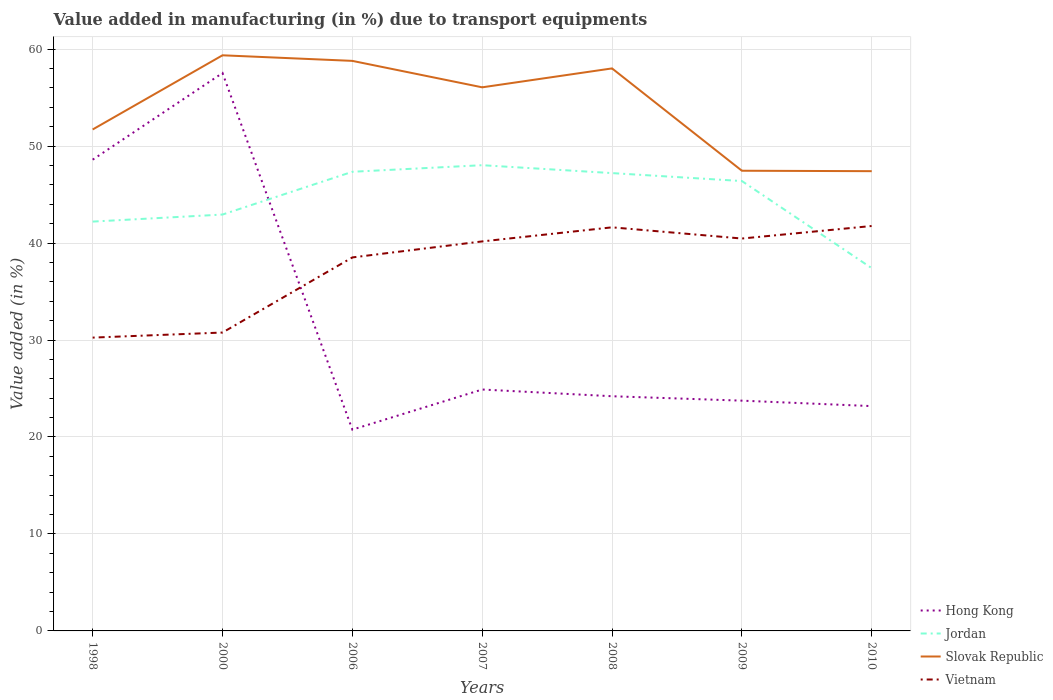How many different coloured lines are there?
Your answer should be very brief. 4. Does the line corresponding to Jordan intersect with the line corresponding to Slovak Republic?
Offer a terse response. No. Across all years, what is the maximum percentage of value added in manufacturing due to transport equipments in Jordan?
Keep it short and to the point. 37.41. What is the total percentage of value added in manufacturing due to transport equipments in Jordan in the graph?
Your answer should be very brief. -0.68. What is the difference between the highest and the second highest percentage of value added in manufacturing due to transport equipments in Hong Kong?
Provide a succinct answer. 36.78. What is the difference between the highest and the lowest percentage of value added in manufacturing due to transport equipments in Slovak Republic?
Your answer should be compact. 4. Is the percentage of value added in manufacturing due to transport equipments in Hong Kong strictly greater than the percentage of value added in manufacturing due to transport equipments in Slovak Republic over the years?
Ensure brevity in your answer.  Yes. How many lines are there?
Give a very brief answer. 4. How many years are there in the graph?
Offer a very short reply. 7. Does the graph contain any zero values?
Make the answer very short. No. What is the title of the graph?
Ensure brevity in your answer.  Value added in manufacturing (in %) due to transport equipments. Does "Israel" appear as one of the legend labels in the graph?
Make the answer very short. No. What is the label or title of the Y-axis?
Offer a very short reply. Value added (in %). What is the Value added (in %) of Hong Kong in 1998?
Your answer should be compact. 48.6. What is the Value added (in %) of Jordan in 1998?
Make the answer very short. 42.21. What is the Value added (in %) in Slovak Republic in 1998?
Give a very brief answer. 51.71. What is the Value added (in %) in Vietnam in 1998?
Your answer should be compact. 30.25. What is the Value added (in %) in Hong Kong in 2000?
Offer a very short reply. 57.54. What is the Value added (in %) of Jordan in 2000?
Offer a very short reply. 42.94. What is the Value added (in %) of Slovak Republic in 2000?
Your answer should be very brief. 59.37. What is the Value added (in %) in Vietnam in 2000?
Offer a terse response. 30.77. What is the Value added (in %) in Hong Kong in 2006?
Your response must be concise. 20.76. What is the Value added (in %) of Jordan in 2006?
Your response must be concise. 47.35. What is the Value added (in %) in Slovak Republic in 2006?
Provide a short and direct response. 58.79. What is the Value added (in %) in Vietnam in 2006?
Your answer should be very brief. 38.52. What is the Value added (in %) of Hong Kong in 2007?
Ensure brevity in your answer.  24.9. What is the Value added (in %) of Jordan in 2007?
Ensure brevity in your answer.  48.03. What is the Value added (in %) in Slovak Republic in 2007?
Your answer should be compact. 56.06. What is the Value added (in %) in Vietnam in 2007?
Make the answer very short. 40.17. What is the Value added (in %) of Hong Kong in 2008?
Provide a succinct answer. 24.2. What is the Value added (in %) of Jordan in 2008?
Offer a terse response. 47.22. What is the Value added (in %) of Slovak Republic in 2008?
Your answer should be compact. 58.01. What is the Value added (in %) in Vietnam in 2008?
Your response must be concise. 41.62. What is the Value added (in %) of Hong Kong in 2009?
Your answer should be compact. 23.75. What is the Value added (in %) of Jordan in 2009?
Offer a terse response. 46.4. What is the Value added (in %) in Slovak Republic in 2009?
Your answer should be very brief. 47.46. What is the Value added (in %) in Vietnam in 2009?
Your answer should be compact. 40.47. What is the Value added (in %) of Hong Kong in 2010?
Give a very brief answer. 23.19. What is the Value added (in %) of Jordan in 2010?
Provide a succinct answer. 37.41. What is the Value added (in %) in Slovak Republic in 2010?
Give a very brief answer. 47.41. What is the Value added (in %) of Vietnam in 2010?
Ensure brevity in your answer.  41.76. Across all years, what is the maximum Value added (in %) of Hong Kong?
Provide a short and direct response. 57.54. Across all years, what is the maximum Value added (in %) in Jordan?
Provide a succinct answer. 48.03. Across all years, what is the maximum Value added (in %) in Slovak Republic?
Your answer should be compact. 59.37. Across all years, what is the maximum Value added (in %) of Vietnam?
Provide a short and direct response. 41.76. Across all years, what is the minimum Value added (in %) in Hong Kong?
Offer a terse response. 20.76. Across all years, what is the minimum Value added (in %) in Jordan?
Keep it short and to the point. 37.41. Across all years, what is the minimum Value added (in %) of Slovak Republic?
Your response must be concise. 47.41. Across all years, what is the minimum Value added (in %) of Vietnam?
Your response must be concise. 30.25. What is the total Value added (in %) in Hong Kong in the graph?
Provide a succinct answer. 222.93. What is the total Value added (in %) of Jordan in the graph?
Your answer should be compact. 311.56. What is the total Value added (in %) of Slovak Republic in the graph?
Offer a terse response. 378.82. What is the total Value added (in %) of Vietnam in the graph?
Keep it short and to the point. 263.57. What is the difference between the Value added (in %) of Hong Kong in 1998 and that in 2000?
Your answer should be very brief. -8.94. What is the difference between the Value added (in %) of Jordan in 1998 and that in 2000?
Provide a short and direct response. -0.73. What is the difference between the Value added (in %) of Slovak Republic in 1998 and that in 2000?
Provide a short and direct response. -7.65. What is the difference between the Value added (in %) of Vietnam in 1998 and that in 2000?
Provide a short and direct response. -0.52. What is the difference between the Value added (in %) of Hong Kong in 1998 and that in 2006?
Keep it short and to the point. 27.84. What is the difference between the Value added (in %) of Jordan in 1998 and that in 2006?
Make the answer very short. -5.14. What is the difference between the Value added (in %) of Slovak Republic in 1998 and that in 2006?
Give a very brief answer. -7.07. What is the difference between the Value added (in %) of Vietnam in 1998 and that in 2006?
Offer a terse response. -8.27. What is the difference between the Value added (in %) in Hong Kong in 1998 and that in 2007?
Provide a succinct answer. 23.7. What is the difference between the Value added (in %) of Jordan in 1998 and that in 2007?
Your answer should be compact. -5.82. What is the difference between the Value added (in %) of Slovak Republic in 1998 and that in 2007?
Give a very brief answer. -4.35. What is the difference between the Value added (in %) in Vietnam in 1998 and that in 2007?
Your answer should be compact. -9.92. What is the difference between the Value added (in %) of Hong Kong in 1998 and that in 2008?
Your answer should be very brief. 24.4. What is the difference between the Value added (in %) in Jordan in 1998 and that in 2008?
Provide a short and direct response. -5. What is the difference between the Value added (in %) in Slovak Republic in 1998 and that in 2008?
Offer a terse response. -6.3. What is the difference between the Value added (in %) in Vietnam in 1998 and that in 2008?
Ensure brevity in your answer.  -11.37. What is the difference between the Value added (in %) in Hong Kong in 1998 and that in 2009?
Your answer should be compact. 24.85. What is the difference between the Value added (in %) of Jordan in 1998 and that in 2009?
Provide a succinct answer. -4.18. What is the difference between the Value added (in %) in Slovak Republic in 1998 and that in 2009?
Keep it short and to the point. 4.25. What is the difference between the Value added (in %) of Vietnam in 1998 and that in 2009?
Keep it short and to the point. -10.22. What is the difference between the Value added (in %) of Hong Kong in 1998 and that in 2010?
Provide a short and direct response. 25.41. What is the difference between the Value added (in %) of Jordan in 1998 and that in 2010?
Keep it short and to the point. 4.8. What is the difference between the Value added (in %) of Slovak Republic in 1998 and that in 2010?
Your answer should be very brief. 4.3. What is the difference between the Value added (in %) of Vietnam in 1998 and that in 2010?
Offer a terse response. -11.51. What is the difference between the Value added (in %) of Hong Kong in 2000 and that in 2006?
Your response must be concise. 36.78. What is the difference between the Value added (in %) in Jordan in 2000 and that in 2006?
Offer a terse response. -4.41. What is the difference between the Value added (in %) of Slovak Republic in 2000 and that in 2006?
Provide a succinct answer. 0.58. What is the difference between the Value added (in %) in Vietnam in 2000 and that in 2006?
Your answer should be compact. -7.75. What is the difference between the Value added (in %) of Hong Kong in 2000 and that in 2007?
Give a very brief answer. 32.64. What is the difference between the Value added (in %) of Jordan in 2000 and that in 2007?
Ensure brevity in your answer.  -5.09. What is the difference between the Value added (in %) of Slovak Republic in 2000 and that in 2007?
Offer a terse response. 3.3. What is the difference between the Value added (in %) in Vietnam in 2000 and that in 2007?
Give a very brief answer. -9.4. What is the difference between the Value added (in %) in Hong Kong in 2000 and that in 2008?
Your response must be concise. 33.33. What is the difference between the Value added (in %) in Jordan in 2000 and that in 2008?
Your response must be concise. -4.28. What is the difference between the Value added (in %) of Slovak Republic in 2000 and that in 2008?
Offer a very short reply. 1.35. What is the difference between the Value added (in %) of Vietnam in 2000 and that in 2008?
Ensure brevity in your answer.  -10.85. What is the difference between the Value added (in %) in Hong Kong in 2000 and that in 2009?
Keep it short and to the point. 33.79. What is the difference between the Value added (in %) of Jordan in 2000 and that in 2009?
Your answer should be compact. -3.46. What is the difference between the Value added (in %) in Slovak Republic in 2000 and that in 2009?
Offer a very short reply. 11.91. What is the difference between the Value added (in %) in Vietnam in 2000 and that in 2009?
Your response must be concise. -9.69. What is the difference between the Value added (in %) in Hong Kong in 2000 and that in 2010?
Your answer should be very brief. 34.35. What is the difference between the Value added (in %) of Jordan in 2000 and that in 2010?
Give a very brief answer. 5.53. What is the difference between the Value added (in %) in Slovak Republic in 2000 and that in 2010?
Make the answer very short. 11.95. What is the difference between the Value added (in %) in Vietnam in 2000 and that in 2010?
Provide a short and direct response. -10.99. What is the difference between the Value added (in %) of Hong Kong in 2006 and that in 2007?
Offer a terse response. -4.14. What is the difference between the Value added (in %) in Jordan in 2006 and that in 2007?
Your answer should be very brief. -0.68. What is the difference between the Value added (in %) in Slovak Republic in 2006 and that in 2007?
Offer a terse response. 2.73. What is the difference between the Value added (in %) of Vietnam in 2006 and that in 2007?
Ensure brevity in your answer.  -1.65. What is the difference between the Value added (in %) of Hong Kong in 2006 and that in 2008?
Make the answer very short. -3.44. What is the difference between the Value added (in %) in Jordan in 2006 and that in 2008?
Your response must be concise. 0.14. What is the difference between the Value added (in %) of Slovak Republic in 2006 and that in 2008?
Give a very brief answer. 0.78. What is the difference between the Value added (in %) of Vietnam in 2006 and that in 2008?
Provide a short and direct response. -3.1. What is the difference between the Value added (in %) of Hong Kong in 2006 and that in 2009?
Ensure brevity in your answer.  -2.99. What is the difference between the Value added (in %) of Jordan in 2006 and that in 2009?
Give a very brief answer. 0.96. What is the difference between the Value added (in %) in Slovak Republic in 2006 and that in 2009?
Your response must be concise. 11.33. What is the difference between the Value added (in %) of Vietnam in 2006 and that in 2009?
Your answer should be compact. -1.95. What is the difference between the Value added (in %) of Hong Kong in 2006 and that in 2010?
Your answer should be very brief. -2.43. What is the difference between the Value added (in %) in Jordan in 2006 and that in 2010?
Keep it short and to the point. 9.94. What is the difference between the Value added (in %) of Slovak Republic in 2006 and that in 2010?
Your answer should be very brief. 11.38. What is the difference between the Value added (in %) in Vietnam in 2006 and that in 2010?
Give a very brief answer. -3.24. What is the difference between the Value added (in %) of Hong Kong in 2007 and that in 2008?
Your response must be concise. 0.69. What is the difference between the Value added (in %) of Jordan in 2007 and that in 2008?
Provide a succinct answer. 0.81. What is the difference between the Value added (in %) in Slovak Republic in 2007 and that in 2008?
Your answer should be compact. -1.95. What is the difference between the Value added (in %) of Vietnam in 2007 and that in 2008?
Provide a short and direct response. -1.45. What is the difference between the Value added (in %) of Hong Kong in 2007 and that in 2009?
Offer a terse response. 1.15. What is the difference between the Value added (in %) in Jordan in 2007 and that in 2009?
Your answer should be very brief. 1.63. What is the difference between the Value added (in %) in Slovak Republic in 2007 and that in 2009?
Your response must be concise. 8.6. What is the difference between the Value added (in %) in Vietnam in 2007 and that in 2009?
Offer a terse response. -0.3. What is the difference between the Value added (in %) in Hong Kong in 2007 and that in 2010?
Make the answer very short. 1.71. What is the difference between the Value added (in %) of Jordan in 2007 and that in 2010?
Ensure brevity in your answer.  10.62. What is the difference between the Value added (in %) of Slovak Republic in 2007 and that in 2010?
Your answer should be compact. 8.65. What is the difference between the Value added (in %) in Vietnam in 2007 and that in 2010?
Offer a terse response. -1.59. What is the difference between the Value added (in %) of Hong Kong in 2008 and that in 2009?
Your response must be concise. 0.46. What is the difference between the Value added (in %) of Jordan in 2008 and that in 2009?
Your answer should be very brief. 0.82. What is the difference between the Value added (in %) of Slovak Republic in 2008 and that in 2009?
Make the answer very short. 10.55. What is the difference between the Value added (in %) in Vietnam in 2008 and that in 2009?
Your answer should be compact. 1.16. What is the difference between the Value added (in %) of Hong Kong in 2008 and that in 2010?
Ensure brevity in your answer.  1.02. What is the difference between the Value added (in %) in Jordan in 2008 and that in 2010?
Your answer should be compact. 9.8. What is the difference between the Value added (in %) in Slovak Republic in 2008 and that in 2010?
Your answer should be very brief. 10.6. What is the difference between the Value added (in %) in Vietnam in 2008 and that in 2010?
Offer a very short reply. -0.14. What is the difference between the Value added (in %) in Hong Kong in 2009 and that in 2010?
Provide a short and direct response. 0.56. What is the difference between the Value added (in %) of Jordan in 2009 and that in 2010?
Make the answer very short. 8.98. What is the difference between the Value added (in %) in Slovak Republic in 2009 and that in 2010?
Offer a terse response. 0.05. What is the difference between the Value added (in %) of Vietnam in 2009 and that in 2010?
Keep it short and to the point. -1.29. What is the difference between the Value added (in %) of Hong Kong in 1998 and the Value added (in %) of Jordan in 2000?
Ensure brevity in your answer.  5.66. What is the difference between the Value added (in %) of Hong Kong in 1998 and the Value added (in %) of Slovak Republic in 2000?
Offer a very short reply. -10.77. What is the difference between the Value added (in %) of Hong Kong in 1998 and the Value added (in %) of Vietnam in 2000?
Ensure brevity in your answer.  17.83. What is the difference between the Value added (in %) of Jordan in 1998 and the Value added (in %) of Slovak Republic in 2000?
Ensure brevity in your answer.  -17.15. What is the difference between the Value added (in %) of Jordan in 1998 and the Value added (in %) of Vietnam in 2000?
Offer a very short reply. 11.44. What is the difference between the Value added (in %) of Slovak Republic in 1998 and the Value added (in %) of Vietnam in 2000?
Your answer should be compact. 20.94. What is the difference between the Value added (in %) of Hong Kong in 1998 and the Value added (in %) of Jordan in 2006?
Your response must be concise. 1.25. What is the difference between the Value added (in %) of Hong Kong in 1998 and the Value added (in %) of Slovak Republic in 2006?
Give a very brief answer. -10.19. What is the difference between the Value added (in %) in Hong Kong in 1998 and the Value added (in %) in Vietnam in 2006?
Your answer should be compact. 10.08. What is the difference between the Value added (in %) in Jordan in 1998 and the Value added (in %) in Slovak Republic in 2006?
Your answer should be very brief. -16.57. What is the difference between the Value added (in %) of Jordan in 1998 and the Value added (in %) of Vietnam in 2006?
Your answer should be compact. 3.69. What is the difference between the Value added (in %) of Slovak Republic in 1998 and the Value added (in %) of Vietnam in 2006?
Ensure brevity in your answer.  13.19. What is the difference between the Value added (in %) in Hong Kong in 1998 and the Value added (in %) in Jordan in 2007?
Your response must be concise. 0.57. What is the difference between the Value added (in %) in Hong Kong in 1998 and the Value added (in %) in Slovak Republic in 2007?
Provide a short and direct response. -7.46. What is the difference between the Value added (in %) of Hong Kong in 1998 and the Value added (in %) of Vietnam in 2007?
Offer a very short reply. 8.43. What is the difference between the Value added (in %) of Jordan in 1998 and the Value added (in %) of Slovak Republic in 2007?
Offer a terse response. -13.85. What is the difference between the Value added (in %) of Jordan in 1998 and the Value added (in %) of Vietnam in 2007?
Provide a short and direct response. 2.04. What is the difference between the Value added (in %) of Slovak Republic in 1998 and the Value added (in %) of Vietnam in 2007?
Your answer should be compact. 11.54. What is the difference between the Value added (in %) in Hong Kong in 1998 and the Value added (in %) in Jordan in 2008?
Your response must be concise. 1.38. What is the difference between the Value added (in %) in Hong Kong in 1998 and the Value added (in %) in Slovak Republic in 2008?
Provide a succinct answer. -9.41. What is the difference between the Value added (in %) of Hong Kong in 1998 and the Value added (in %) of Vietnam in 2008?
Ensure brevity in your answer.  6.98. What is the difference between the Value added (in %) in Jordan in 1998 and the Value added (in %) in Slovak Republic in 2008?
Your response must be concise. -15.8. What is the difference between the Value added (in %) of Jordan in 1998 and the Value added (in %) of Vietnam in 2008?
Give a very brief answer. 0.59. What is the difference between the Value added (in %) in Slovak Republic in 1998 and the Value added (in %) in Vietnam in 2008?
Offer a very short reply. 10.09. What is the difference between the Value added (in %) in Hong Kong in 1998 and the Value added (in %) in Jordan in 2009?
Your answer should be very brief. 2.2. What is the difference between the Value added (in %) of Hong Kong in 1998 and the Value added (in %) of Slovak Republic in 2009?
Offer a very short reply. 1.14. What is the difference between the Value added (in %) of Hong Kong in 1998 and the Value added (in %) of Vietnam in 2009?
Provide a short and direct response. 8.13. What is the difference between the Value added (in %) of Jordan in 1998 and the Value added (in %) of Slovak Republic in 2009?
Offer a terse response. -5.25. What is the difference between the Value added (in %) in Jordan in 1998 and the Value added (in %) in Vietnam in 2009?
Offer a terse response. 1.75. What is the difference between the Value added (in %) in Slovak Republic in 1998 and the Value added (in %) in Vietnam in 2009?
Your response must be concise. 11.25. What is the difference between the Value added (in %) in Hong Kong in 1998 and the Value added (in %) in Jordan in 2010?
Your answer should be compact. 11.19. What is the difference between the Value added (in %) of Hong Kong in 1998 and the Value added (in %) of Slovak Republic in 2010?
Give a very brief answer. 1.19. What is the difference between the Value added (in %) of Hong Kong in 1998 and the Value added (in %) of Vietnam in 2010?
Provide a succinct answer. 6.84. What is the difference between the Value added (in %) in Jordan in 1998 and the Value added (in %) in Slovak Republic in 2010?
Your answer should be compact. -5.2. What is the difference between the Value added (in %) of Jordan in 1998 and the Value added (in %) of Vietnam in 2010?
Your response must be concise. 0.45. What is the difference between the Value added (in %) of Slovak Republic in 1998 and the Value added (in %) of Vietnam in 2010?
Offer a very short reply. 9.95. What is the difference between the Value added (in %) of Hong Kong in 2000 and the Value added (in %) of Jordan in 2006?
Your response must be concise. 10.18. What is the difference between the Value added (in %) of Hong Kong in 2000 and the Value added (in %) of Slovak Republic in 2006?
Your answer should be very brief. -1.25. What is the difference between the Value added (in %) of Hong Kong in 2000 and the Value added (in %) of Vietnam in 2006?
Your answer should be very brief. 19.02. What is the difference between the Value added (in %) of Jordan in 2000 and the Value added (in %) of Slovak Republic in 2006?
Provide a succinct answer. -15.85. What is the difference between the Value added (in %) in Jordan in 2000 and the Value added (in %) in Vietnam in 2006?
Keep it short and to the point. 4.42. What is the difference between the Value added (in %) of Slovak Republic in 2000 and the Value added (in %) of Vietnam in 2006?
Your answer should be compact. 20.85. What is the difference between the Value added (in %) in Hong Kong in 2000 and the Value added (in %) in Jordan in 2007?
Offer a very short reply. 9.5. What is the difference between the Value added (in %) of Hong Kong in 2000 and the Value added (in %) of Slovak Republic in 2007?
Offer a very short reply. 1.47. What is the difference between the Value added (in %) of Hong Kong in 2000 and the Value added (in %) of Vietnam in 2007?
Offer a terse response. 17.36. What is the difference between the Value added (in %) in Jordan in 2000 and the Value added (in %) in Slovak Republic in 2007?
Provide a short and direct response. -13.12. What is the difference between the Value added (in %) in Jordan in 2000 and the Value added (in %) in Vietnam in 2007?
Your response must be concise. 2.77. What is the difference between the Value added (in %) of Slovak Republic in 2000 and the Value added (in %) of Vietnam in 2007?
Provide a succinct answer. 19.19. What is the difference between the Value added (in %) of Hong Kong in 2000 and the Value added (in %) of Jordan in 2008?
Offer a very short reply. 10.32. What is the difference between the Value added (in %) of Hong Kong in 2000 and the Value added (in %) of Slovak Republic in 2008?
Provide a succinct answer. -0.48. What is the difference between the Value added (in %) of Hong Kong in 2000 and the Value added (in %) of Vietnam in 2008?
Offer a terse response. 15.91. What is the difference between the Value added (in %) of Jordan in 2000 and the Value added (in %) of Slovak Republic in 2008?
Your response must be concise. -15.07. What is the difference between the Value added (in %) in Jordan in 2000 and the Value added (in %) in Vietnam in 2008?
Offer a terse response. 1.32. What is the difference between the Value added (in %) of Slovak Republic in 2000 and the Value added (in %) of Vietnam in 2008?
Ensure brevity in your answer.  17.74. What is the difference between the Value added (in %) in Hong Kong in 2000 and the Value added (in %) in Jordan in 2009?
Provide a short and direct response. 11.14. What is the difference between the Value added (in %) of Hong Kong in 2000 and the Value added (in %) of Slovak Republic in 2009?
Make the answer very short. 10.08. What is the difference between the Value added (in %) in Hong Kong in 2000 and the Value added (in %) in Vietnam in 2009?
Provide a short and direct response. 17.07. What is the difference between the Value added (in %) of Jordan in 2000 and the Value added (in %) of Slovak Republic in 2009?
Provide a succinct answer. -4.52. What is the difference between the Value added (in %) in Jordan in 2000 and the Value added (in %) in Vietnam in 2009?
Ensure brevity in your answer.  2.47. What is the difference between the Value added (in %) of Slovak Republic in 2000 and the Value added (in %) of Vietnam in 2009?
Your answer should be very brief. 18.9. What is the difference between the Value added (in %) in Hong Kong in 2000 and the Value added (in %) in Jordan in 2010?
Give a very brief answer. 20.12. What is the difference between the Value added (in %) of Hong Kong in 2000 and the Value added (in %) of Slovak Republic in 2010?
Provide a short and direct response. 10.12. What is the difference between the Value added (in %) in Hong Kong in 2000 and the Value added (in %) in Vietnam in 2010?
Provide a succinct answer. 15.77. What is the difference between the Value added (in %) of Jordan in 2000 and the Value added (in %) of Slovak Republic in 2010?
Provide a succinct answer. -4.47. What is the difference between the Value added (in %) of Jordan in 2000 and the Value added (in %) of Vietnam in 2010?
Your response must be concise. 1.18. What is the difference between the Value added (in %) of Slovak Republic in 2000 and the Value added (in %) of Vietnam in 2010?
Ensure brevity in your answer.  17.6. What is the difference between the Value added (in %) of Hong Kong in 2006 and the Value added (in %) of Jordan in 2007?
Offer a terse response. -27.27. What is the difference between the Value added (in %) of Hong Kong in 2006 and the Value added (in %) of Slovak Republic in 2007?
Offer a very short reply. -35.3. What is the difference between the Value added (in %) in Hong Kong in 2006 and the Value added (in %) in Vietnam in 2007?
Give a very brief answer. -19.41. What is the difference between the Value added (in %) in Jordan in 2006 and the Value added (in %) in Slovak Republic in 2007?
Provide a short and direct response. -8.71. What is the difference between the Value added (in %) of Jordan in 2006 and the Value added (in %) of Vietnam in 2007?
Your response must be concise. 7.18. What is the difference between the Value added (in %) in Slovak Republic in 2006 and the Value added (in %) in Vietnam in 2007?
Provide a succinct answer. 18.62. What is the difference between the Value added (in %) in Hong Kong in 2006 and the Value added (in %) in Jordan in 2008?
Ensure brevity in your answer.  -26.46. What is the difference between the Value added (in %) of Hong Kong in 2006 and the Value added (in %) of Slovak Republic in 2008?
Make the answer very short. -37.25. What is the difference between the Value added (in %) of Hong Kong in 2006 and the Value added (in %) of Vietnam in 2008?
Your answer should be compact. -20.86. What is the difference between the Value added (in %) of Jordan in 2006 and the Value added (in %) of Slovak Republic in 2008?
Give a very brief answer. -10.66. What is the difference between the Value added (in %) of Jordan in 2006 and the Value added (in %) of Vietnam in 2008?
Ensure brevity in your answer.  5.73. What is the difference between the Value added (in %) of Slovak Republic in 2006 and the Value added (in %) of Vietnam in 2008?
Provide a short and direct response. 17.17. What is the difference between the Value added (in %) of Hong Kong in 2006 and the Value added (in %) of Jordan in 2009?
Offer a terse response. -25.64. What is the difference between the Value added (in %) of Hong Kong in 2006 and the Value added (in %) of Slovak Republic in 2009?
Your response must be concise. -26.7. What is the difference between the Value added (in %) of Hong Kong in 2006 and the Value added (in %) of Vietnam in 2009?
Your answer should be compact. -19.71. What is the difference between the Value added (in %) in Jordan in 2006 and the Value added (in %) in Slovak Republic in 2009?
Your answer should be compact. -0.11. What is the difference between the Value added (in %) of Jordan in 2006 and the Value added (in %) of Vietnam in 2009?
Keep it short and to the point. 6.89. What is the difference between the Value added (in %) of Slovak Republic in 2006 and the Value added (in %) of Vietnam in 2009?
Your answer should be compact. 18.32. What is the difference between the Value added (in %) of Hong Kong in 2006 and the Value added (in %) of Jordan in 2010?
Offer a very short reply. -16.65. What is the difference between the Value added (in %) of Hong Kong in 2006 and the Value added (in %) of Slovak Republic in 2010?
Offer a very short reply. -26.65. What is the difference between the Value added (in %) of Hong Kong in 2006 and the Value added (in %) of Vietnam in 2010?
Offer a very short reply. -21. What is the difference between the Value added (in %) of Jordan in 2006 and the Value added (in %) of Slovak Republic in 2010?
Give a very brief answer. -0.06. What is the difference between the Value added (in %) of Jordan in 2006 and the Value added (in %) of Vietnam in 2010?
Your answer should be compact. 5.59. What is the difference between the Value added (in %) of Slovak Republic in 2006 and the Value added (in %) of Vietnam in 2010?
Your answer should be very brief. 17.03. What is the difference between the Value added (in %) in Hong Kong in 2007 and the Value added (in %) in Jordan in 2008?
Provide a short and direct response. -22.32. What is the difference between the Value added (in %) of Hong Kong in 2007 and the Value added (in %) of Slovak Republic in 2008?
Offer a very short reply. -33.12. What is the difference between the Value added (in %) of Hong Kong in 2007 and the Value added (in %) of Vietnam in 2008?
Offer a terse response. -16.73. What is the difference between the Value added (in %) in Jordan in 2007 and the Value added (in %) in Slovak Republic in 2008?
Keep it short and to the point. -9.98. What is the difference between the Value added (in %) of Jordan in 2007 and the Value added (in %) of Vietnam in 2008?
Keep it short and to the point. 6.41. What is the difference between the Value added (in %) in Slovak Republic in 2007 and the Value added (in %) in Vietnam in 2008?
Offer a terse response. 14.44. What is the difference between the Value added (in %) in Hong Kong in 2007 and the Value added (in %) in Jordan in 2009?
Give a very brief answer. -21.5. What is the difference between the Value added (in %) of Hong Kong in 2007 and the Value added (in %) of Slovak Republic in 2009?
Keep it short and to the point. -22.56. What is the difference between the Value added (in %) in Hong Kong in 2007 and the Value added (in %) in Vietnam in 2009?
Make the answer very short. -15.57. What is the difference between the Value added (in %) in Jordan in 2007 and the Value added (in %) in Slovak Republic in 2009?
Give a very brief answer. 0.57. What is the difference between the Value added (in %) in Jordan in 2007 and the Value added (in %) in Vietnam in 2009?
Offer a terse response. 7.56. What is the difference between the Value added (in %) in Slovak Republic in 2007 and the Value added (in %) in Vietnam in 2009?
Ensure brevity in your answer.  15.6. What is the difference between the Value added (in %) in Hong Kong in 2007 and the Value added (in %) in Jordan in 2010?
Give a very brief answer. -12.52. What is the difference between the Value added (in %) in Hong Kong in 2007 and the Value added (in %) in Slovak Republic in 2010?
Your response must be concise. -22.52. What is the difference between the Value added (in %) in Hong Kong in 2007 and the Value added (in %) in Vietnam in 2010?
Provide a succinct answer. -16.86. What is the difference between the Value added (in %) of Jordan in 2007 and the Value added (in %) of Slovak Republic in 2010?
Make the answer very short. 0.62. What is the difference between the Value added (in %) in Jordan in 2007 and the Value added (in %) in Vietnam in 2010?
Provide a short and direct response. 6.27. What is the difference between the Value added (in %) of Slovak Republic in 2007 and the Value added (in %) of Vietnam in 2010?
Make the answer very short. 14.3. What is the difference between the Value added (in %) in Hong Kong in 2008 and the Value added (in %) in Jordan in 2009?
Provide a succinct answer. -22.19. What is the difference between the Value added (in %) in Hong Kong in 2008 and the Value added (in %) in Slovak Republic in 2009?
Make the answer very short. -23.26. What is the difference between the Value added (in %) of Hong Kong in 2008 and the Value added (in %) of Vietnam in 2009?
Offer a terse response. -16.26. What is the difference between the Value added (in %) of Jordan in 2008 and the Value added (in %) of Slovak Republic in 2009?
Provide a succinct answer. -0.24. What is the difference between the Value added (in %) in Jordan in 2008 and the Value added (in %) in Vietnam in 2009?
Your response must be concise. 6.75. What is the difference between the Value added (in %) of Slovak Republic in 2008 and the Value added (in %) of Vietnam in 2009?
Your answer should be very brief. 17.55. What is the difference between the Value added (in %) of Hong Kong in 2008 and the Value added (in %) of Jordan in 2010?
Give a very brief answer. -13.21. What is the difference between the Value added (in %) in Hong Kong in 2008 and the Value added (in %) in Slovak Republic in 2010?
Ensure brevity in your answer.  -23.21. What is the difference between the Value added (in %) of Hong Kong in 2008 and the Value added (in %) of Vietnam in 2010?
Provide a short and direct response. -17.56. What is the difference between the Value added (in %) in Jordan in 2008 and the Value added (in %) in Slovak Republic in 2010?
Provide a succinct answer. -0.2. What is the difference between the Value added (in %) in Jordan in 2008 and the Value added (in %) in Vietnam in 2010?
Your response must be concise. 5.46. What is the difference between the Value added (in %) of Slovak Republic in 2008 and the Value added (in %) of Vietnam in 2010?
Ensure brevity in your answer.  16.25. What is the difference between the Value added (in %) in Hong Kong in 2009 and the Value added (in %) in Jordan in 2010?
Give a very brief answer. -13.66. What is the difference between the Value added (in %) in Hong Kong in 2009 and the Value added (in %) in Slovak Republic in 2010?
Your answer should be very brief. -23.67. What is the difference between the Value added (in %) of Hong Kong in 2009 and the Value added (in %) of Vietnam in 2010?
Offer a terse response. -18.01. What is the difference between the Value added (in %) in Jordan in 2009 and the Value added (in %) in Slovak Republic in 2010?
Your answer should be compact. -1.02. What is the difference between the Value added (in %) in Jordan in 2009 and the Value added (in %) in Vietnam in 2010?
Offer a terse response. 4.64. What is the difference between the Value added (in %) of Slovak Republic in 2009 and the Value added (in %) of Vietnam in 2010?
Offer a very short reply. 5.7. What is the average Value added (in %) of Hong Kong per year?
Ensure brevity in your answer.  31.85. What is the average Value added (in %) of Jordan per year?
Keep it short and to the point. 44.51. What is the average Value added (in %) of Slovak Republic per year?
Give a very brief answer. 54.12. What is the average Value added (in %) in Vietnam per year?
Offer a very short reply. 37.65. In the year 1998, what is the difference between the Value added (in %) of Hong Kong and Value added (in %) of Jordan?
Ensure brevity in your answer.  6.39. In the year 1998, what is the difference between the Value added (in %) in Hong Kong and Value added (in %) in Slovak Republic?
Give a very brief answer. -3.11. In the year 1998, what is the difference between the Value added (in %) in Hong Kong and Value added (in %) in Vietnam?
Keep it short and to the point. 18.35. In the year 1998, what is the difference between the Value added (in %) in Jordan and Value added (in %) in Slovak Republic?
Provide a short and direct response. -9.5. In the year 1998, what is the difference between the Value added (in %) in Jordan and Value added (in %) in Vietnam?
Keep it short and to the point. 11.96. In the year 1998, what is the difference between the Value added (in %) in Slovak Republic and Value added (in %) in Vietnam?
Make the answer very short. 21.46. In the year 2000, what is the difference between the Value added (in %) of Hong Kong and Value added (in %) of Jordan?
Make the answer very short. 14.59. In the year 2000, what is the difference between the Value added (in %) in Hong Kong and Value added (in %) in Slovak Republic?
Offer a terse response. -1.83. In the year 2000, what is the difference between the Value added (in %) in Hong Kong and Value added (in %) in Vietnam?
Your answer should be compact. 26.76. In the year 2000, what is the difference between the Value added (in %) in Jordan and Value added (in %) in Slovak Republic?
Give a very brief answer. -16.42. In the year 2000, what is the difference between the Value added (in %) in Jordan and Value added (in %) in Vietnam?
Your answer should be very brief. 12.17. In the year 2000, what is the difference between the Value added (in %) of Slovak Republic and Value added (in %) of Vietnam?
Your response must be concise. 28.59. In the year 2006, what is the difference between the Value added (in %) of Hong Kong and Value added (in %) of Jordan?
Give a very brief answer. -26.59. In the year 2006, what is the difference between the Value added (in %) of Hong Kong and Value added (in %) of Slovak Republic?
Give a very brief answer. -38.03. In the year 2006, what is the difference between the Value added (in %) in Hong Kong and Value added (in %) in Vietnam?
Make the answer very short. -17.76. In the year 2006, what is the difference between the Value added (in %) in Jordan and Value added (in %) in Slovak Republic?
Ensure brevity in your answer.  -11.44. In the year 2006, what is the difference between the Value added (in %) of Jordan and Value added (in %) of Vietnam?
Ensure brevity in your answer.  8.83. In the year 2006, what is the difference between the Value added (in %) in Slovak Republic and Value added (in %) in Vietnam?
Make the answer very short. 20.27. In the year 2007, what is the difference between the Value added (in %) of Hong Kong and Value added (in %) of Jordan?
Make the answer very short. -23.13. In the year 2007, what is the difference between the Value added (in %) in Hong Kong and Value added (in %) in Slovak Republic?
Your answer should be very brief. -31.17. In the year 2007, what is the difference between the Value added (in %) of Hong Kong and Value added (in %) of Vietnam?
Provide a short and direct response. -15.27. In the year 2007, what is the difference between the Value added (in %) of Jordan and Value added (in %) of Slovak Republic?
Keep it short and to the point. -8.03. In the year 2007, what is the difference between the Value added (in %) in Jordan and Value added (in %) in Vietnam?
Offer a very short reply. 7.86. In the year 2007, what is the difference between the Value added (in %) of Slovak Republic and Value added (in %) of Vietnam?
Make the answer very short. 15.89. In the year 2008, what is the difference between the Value added (in %) in Hong Kong and Value added (in %) in Jordan?
Your answer should be compact. -23.01. In the year 2008, what is the difference between the Value added (in %) of Hong Kong and Value added (in %) of Slovak Republic?
Provide a short and direct response. -33.81. In the year 2008, what is the difference between the Value added (in %) in Hong Kong and Value added (in %) in Vietnam?
Your answer should be very brief. -17.42. In the year 2008, what is the difference between the Value added (in %) of Jordan and Value added (in %) of Slovak Republic?
Ensure brevity in your answer.  -10.8. In the year 2008, what is the difference between the Value added (in %) of Jordan and Value added (in %) of Vietnam?
Your response must be concise. 5.59. In the year 2008, what is the difference between the Value added (in %) of Slovak Republic and Value added (in %) of Vietnam?
Give a very brief answer. 16.39. In the year 2009, what is the difference between the Value added (in %) of Hong Kong and Value added (in %) of Jordan?
Your response must be concise. -22.65. In the year 2009, what is the difference between the Value added (in %) of Hong Kong and Value added (in %) of Slovak Republic?
Keep it short and to the point. -23.71. In the year 2009, what is the difference between the Value added (in %) in Hong Kong and Value added (in %) in Vietnam?
Your answer should be compact. -16.72. In the year 2009, what is the difference between the Value added (in %) in Jordan and Value added (in %) in Slovak Republic?
Keep it short and to the point. -1.06. In the year 2009, what is the difference between the Value added (in %) of Jordan and Value added (in %) of Vietnam?
Your answer should be very brief. 5.93. In the year 2009, what is the difference between the Value added (in %) of Slovak Republic and Value added (in %) of Vietnam?
Your response must be concise. 6.99. In the year 2010, what is the difference between the Value added (in %) of Hong Kong and Value added (in %) of Jordan?
Your answer should be very brief. -14.23. In the year 2010, what is the difference between the Value added (in %) in Hong Kong and Value added (in %) in Slovak Republic?
Offer a terse response. -24.23. In the year 2010, what is the difference between the Value added (in %) in Hong Kong and Value added (in %) in Vietnam?
Make the answer very short. -18.58. In the year 2010, what is the difference between the Value added (in %) of Jordan and Value added (in %) of Slovak Republic?
Your answer should be compact. -10. In the year 2010, what is the difference between the Value added (in %) in Jordan and Value added (in %) in Vietnam?
Keep it short and to the point. -4.35. In the year 2010, what is the difference between the Value added (in %) of Slovak Republic and Value added (in %) of Vietnam?
Offer a terse response. 5.65. What is the ratio of the Value added (in %) in Hong Kong in 1998 to that in 2000?
Give a very brief answer. 0.84. What is the ratio of the Value added (in %) of Jordan in 1998 to that in 2000?
Provide a short and direct response. 0.98. What is the ratio of the Value added (in %) of Slovak Republic in 1998 to that in 2000?
Your answer should be very brief. 0.87. What is the ratio of the Value added (in %) of Vietnam in 1998 to that in 2000?
Give a very brief answer. 0.98. What is the ratio of the Value added (in %) of Hong Kong in 1998 to that in 2006?
Make the answer very short. 2.34. What is the ratio of the Value added (in %) of Jordan in 1998 to that in 2006?
Offer a very short reply. 0.89. What is the ratio of the Value added (in %) of Slovak Republic in 1998 to that in 2006?
Your answer should be very brief. 0.88. What is the ratio of the Value added (in %) in Vietnam in 1998 to that in 2006?
Offer a very short reply. 0.79. What is the ratio of the Value added (in %) in Hong Kong in 1998 to that in 2007?
Your response must be concise. 1.95. What is the ratio of the Value added (in %) of Jordan in 1998 to that in 2007?
Provide a short and direct response. 0.88. What is the ratio of the Value added (in %) of Slovak Republic in 1998 to that in 2007?
Ensure brevity in your answer.  0.92. What is the ratio of the Value added (in %) of Vietnam in 1998 to that in 2007?
Make the answer very short. 0.75. What is the ratio of the Value added (in %) of Hong Kong in 1998 to that in 2008?
Provide a short and direct response. 2.01. What is the ratio of the Value added (in %) of Jordan in 1998 to that in 2008?
Offer a terse response. 0.89. What is the ratio of the Value added (in %) of Slovak Republic in 1998 to that in 2008?
Ensure brevity in your answer.  0.89. What is the ratio of the Value added (in %) in Vietnam in 1998 to that in 2008?
Your answer should be compact. 0.73. What is the ratio of the Value added (in %) in Hong Kong in 1998 to that in 2009?
Your answer should be compact. 2.05. What is the ratio of the Value added (in %) in Jordan in 1998 to that in 2009?
Provide a succinct answer. 0.91. What is the ratio of the Value added (in %) in Slovak Republic in 1998 to that in 2009?
Ensure brevity in your answer.  1.09. What is the ratio of the Value added (in %) in Vietnam in 1998 to that in 2009?
Offer a terse response. 0.75. What is the ratio of the Value added (in %) of Hong Kong in 1998 to that in 2010?
Provide a short and direct response. 2.1. What is the ratio of the Value added (in %) in Jordan in 1998 to that in 2010?
Provide a succinct answer. 1.13. What is the ratio of the Value added (in %) in Slovak Republic in 1998 to that in 2010?
Make the answer very short. 1.09. What is the ratio of the Value added (in %) in Vietnam in 1998 to that in 2010?
Offer a terse response. 0.72. What is the ratio of the Value added (in %) in Hong Kong in 2000 to that in 2006?
Offer a terse response. 2.77. What is the ratio of the Value added (in %) in Jordan in 2000 to that in 2006?
Your answer should be compact. 0.91. What is the ratio of the Value added (in %) in Slovak Republic in 2000 to that in 2006?
Offer a very short reply. 1.01. What is the ratio of the Value added (in %) in Vietnam in 2000 to that in 2006?
Your response must be concise. 0.8. What is the ratio of the Value added (in %) in Hong Kong in 2000 to that in 2007?
Provide a succinct answer. 2.31. What is the ratio of the Value added (in %) in Jordan in 2000 to that in 2007?
Your answer should be compact. 0.89. What is the ratio of the Value added (in %) of Slovak Republic in 2000 to that in 2007?
Your response must be concise. 1.06. What is the ratio of the Value added (in %) of Vietnam in 2000 to that in 2007?
Provide a short and direct response. 0.77. What is the ratio of the Value added (in %) of Hong Kong in 2000 to that in 2008?
Give a very brief answer. 2.38. What is the ratio of the Value added (in %) of Jordan in 2000 to that in 2008?
Provide a succinct answer. 0.91. What is the ratio of the Value added (in %) of Slovak Republic in 2000 to that in 2008?
Your answer should be very brief. 1.02. What is the ratio of the Value added (in %) of Vietnam in 2000 to that in 2008?
Your answer should be very brief. 0.74. What is the ratio of the Value added (in %) of Hong Kong in 2000 to that in 2009?
Give a very brief answer. 2.42. What is the ratio of the Value added (in %) in Jordan in 2000 to that in 2009?
Your answer should be very brief. 0.93. What is the ratio of the Value added (in %) of Slovak Republic in 2000 to that in 2009?
Provide a succinct answer. 1.25. What is the ratio of the Value added (in %) in Vietnam in 2000 to that in 2009?
Your answer should be very brief. 0.76. What is the ratio of the Value added (in %) of Hong Kong in 2000 to that in 2010?
Your answer should be compact. 2.48. What is the ratio of the Value added (in %) in Jordan in 2000 to that in 2010?
Offer a terse response. 1.15. What is the ratio of the Value added (in %) in Slovak Republic in 2000 to that in 2010?
Your response must be concise. 1.25. What is the ratio of the Value added (in %) of Vietnam in 2000 to that in 2010?
Offer a very short reply. 0.74. What is the ratio of the Value added (in %) in Hong Kong in 2006 to that in 2007?
Keep it short and to the point. 0.83. What is the ratio of the Value added (in %) in Jordan in 2006 to that in 2007?
Your response must be concise. 0.99. What is the ratio of the Value added (in %) in Slovak Republic in 2006 to that in 2007?
Your answer should be compact. 1.05. What is the ratio of the Value added (in %) in Vietnam in 2006 to that in 2007?
Offer a very short reply. 0.96. What is the ratio of the Value added (in %) of Hong Kong in 2006 to that in 2008?
Provide a succinct answer. 0.86. What is the ratio of the Value added (in %) in Slovak Republic in 2006 to that in 2008?
Ensure brevity in your answer.  1.01. What is the ratio of the Value added (in %) in Vietnam in 2006 to that in 2008?
Offer a very short reply. 0.93. What is the ratio of the Value added (in %) in Hong Kong in 2006 to that in 2009?
Provide a short and direct response. 0.87. What is the ratio of the Value added (in %) in Jordan in 2006 to that in 2009?
Offer a very short reply. 1.02. What is the ratio of the Value added (in %) of Slovak Republic in 2006 to that in 2009?
Your answer should be very brief. 1.24. What is the ratio of the Value added (in %) of Vietnam in 2006 to that in 2009?
Your response must be concise. 0.95. What is the ratio of the Value added (in %) of Hong Kong in 2006 to that in 2010?
Keep it short and to the point. 0.9. What is the ratio of the Value added (in %) in Jordan in 2006 to that in 2010?
Provide a short and direct response. 1.27. What is the ratio of the Value added (in %) of Slovak Republic in 2006 to that in 2010?
Provide a short and direct response. 1.24. What is the ratio of the Value added (in %) in Vietnam in 2006 to that in 2010?
Offer a very short reply. 0.92. What is the ratio of the Value added (in %) in Hong Kong in 2007 to that in 2008?
Provide a short and direct response. 1.03. What is the ratio of the Value added (in %) of Jordan in 2007 to that in 2008?
Your response must be concise. 1.02. What is the ratio of the Value added (in %) of Slovak Republic in 2007 to that in 2008?
Offer a terse response. 0.97. What is the ratio of the Value added (in %) in Vietnam in 2007 to that in 2008?
Your answer should be compact. 0.97. What is the ratio of the Value added (in %) in Hong Kong in 2007 to that in 2009?
Your answer should be compact. 1.05. What is the ratio of the Value added (in %) of Jordan in 2007 to that in 2009?
Your answer should be compact. 1.04. What is the ratio of the Value added (in %) in Slovak Republic in 2007 to that in 2009?
Give a very brief answer. 1.18. What is the ratio of the Value added (in %) of Hong Kong in 2007 to that in 2010?
Provide a short and direct response. 1.07. What is the ratio of the Value added (in %) of Jordan in 2007 to that in 2010?
Keep it short and to the point. 1.28. What is the ratio of the Value added (in %) in Slovak Republic in 2007 to that in 2010?
Offer a very short reply. 1.18. What is the ratio of the Value added (in %) of Vietnam in 2007 to that in 2010?
Provide a succinct answer. 0.96. What is the ratio of the Value added (in %) of Hong Kong in 2008 to that in 2009?
Keep it short and to the point. 1.02. What is the ratio of the Value added (in %) in Jordan in 2008 to that in 2009?
Give a very brief answer. 1.02. What is the ratio of the Value added (in %) in Slovak Republic in 2008 to that in 2009?
Keep it short and to the point. 1.22. What is the ratio of the Value added (in %) in Vietnam in 2008 to that in 2009?
Provide a succinct answer. 1.03. What is the ratio of the Value added (in %) in Hong Kong in 2008 to that in 2010?
Offer a very short reply. 1.04. What is the ratio of the Value added (in %) in Jordan in 2008 to that in 2010?
Keep it short and to the point. 1.26. What is the ratio of the Value added (in %) in Slovak Republic in 2008 to that in 2010?
Your answer should be very brief. 1.22. What is the ratio of the Value added (in %) in Hong Kong in 2009 to that in 2010?
Make the answer very short. 1.02. What is the ratio of the Value added (in %) in Jordan in 2009 to that in 2010?
Provide a succinct answer. 1.24. What is the difference between the highest and the second highest Value added (in %) in Hong Kong?
Your answer should be compact. 8.94. What is the difference between the highest and the second highest Value added (in %) in Jordan?
Provide a short and direct response. 0.68. What is the difference between the highest and the second highest Value added (in %) of Slovak Republic?
Provide a succinct answer. 0.58. What is the difference between the highest and the second highest Value added (in %) of Vietnam?
Your answer should be very brief. 0.14. What is the difference between the highest and the lowest Value added (in %) in Hong Kong?
Your answer should be compact. 36.78. What is the difference between the highest and the lowest Value added (in %) of Jordan?
Provide a succinct answer. 10.62. What is the difference between the highest and the lowest Value added (in %) of Slovak Republic?
Make the answer very short. 11.95. What is the difference between the highest and the lowest Value added (in %) of Vietnam?
Ensure brevity in your answer.  11.51. 